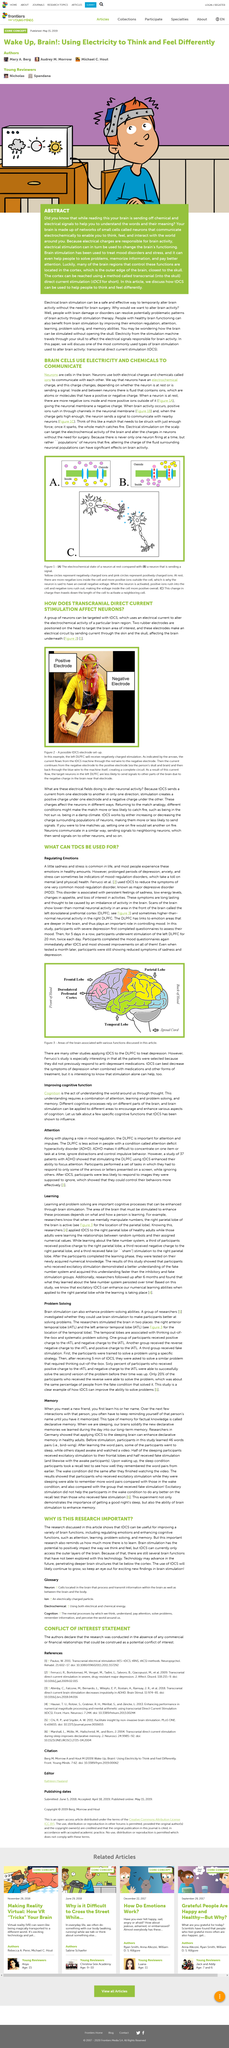Highlight a few significant elements in this photo. Figure C demonstrates a neuron with a large soma, multiple dendrites, and a single, large axon. Brain cells communicate using both electricity and chemicals, as stated. Long periods of depression, anxiety, and stress can have a negative impact on both mental and physical health, as they can lead to a range of negative outcomes, including poor physical health and mental health issues. Yes, neurons send signals to neighboring neurons. Prolonged periods of depression, anxiety, and stress can be indicators of mood-regulated disorders. In fact, these symptoms may be a clear sign of such conditions. 